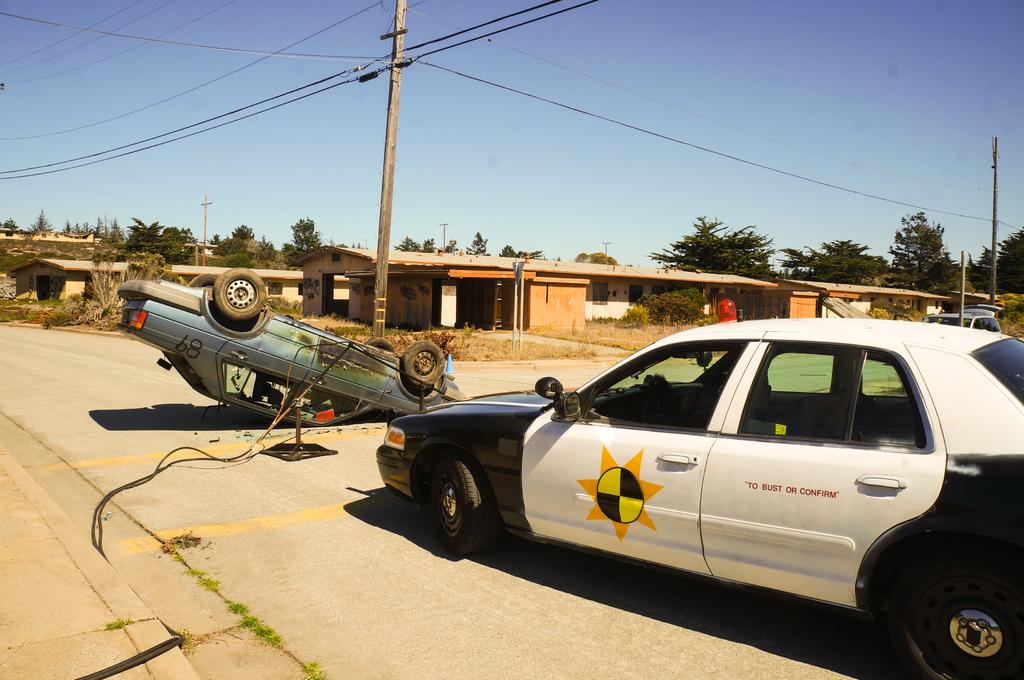What is written on the black and white car?
Your answer should be compact. To bust or confirm. What number is on the blue car?
Your answer should be compact. 89. 